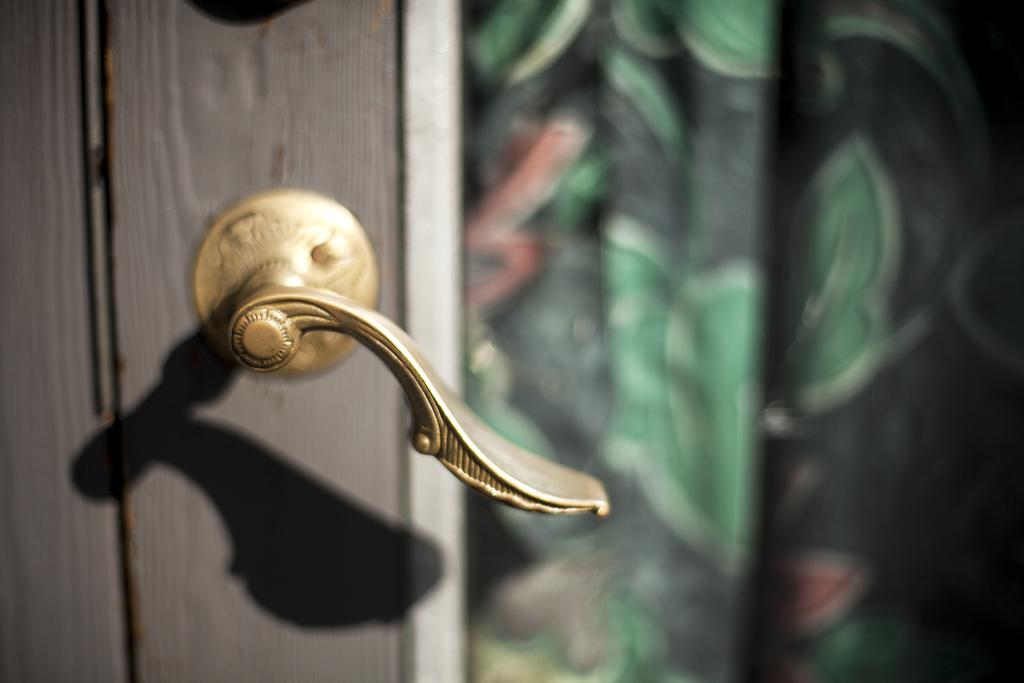What can be seen in the image that is used to open or close a door? There is a door handle in the image. Can you describe the overall clarity of the image? The image is blurred. What flavor of ice cream is being served on the street in the image? There is no ice cream or street present in the image; it only features a door handle. 